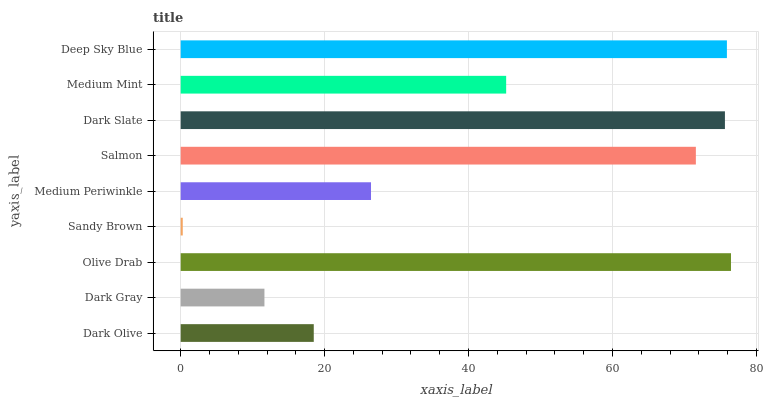Is Sandy Brown the minimum?
Answer yes or no. Yes. Is Olive Drab the maximum?
Answer yes or no. Yes. Is Dark Gray the minimum?
Answer yes or no. No. Is Dark Gray the maximum?
Answer yes or no. No. Is Dark Olive greater than Dark Gray?
Answer yes or no. Yes. Is Dark Gray less than Dark Olive?
Answer yes or no. Yes. Is Dark Gray greater than Dark Olive?
Answer yes or no. No. Is Dark Olive less than Dark Gray?
Answer yes or no. No. Is Medium Mint the high median?
Answer yes or no. Yes. Is Medium Mint the low median?
Answer yes or no. Yes. Is Dark Olive the high median?
Answer yes or no. No. Is Salmon the low median?
Answer yes or no. No. 